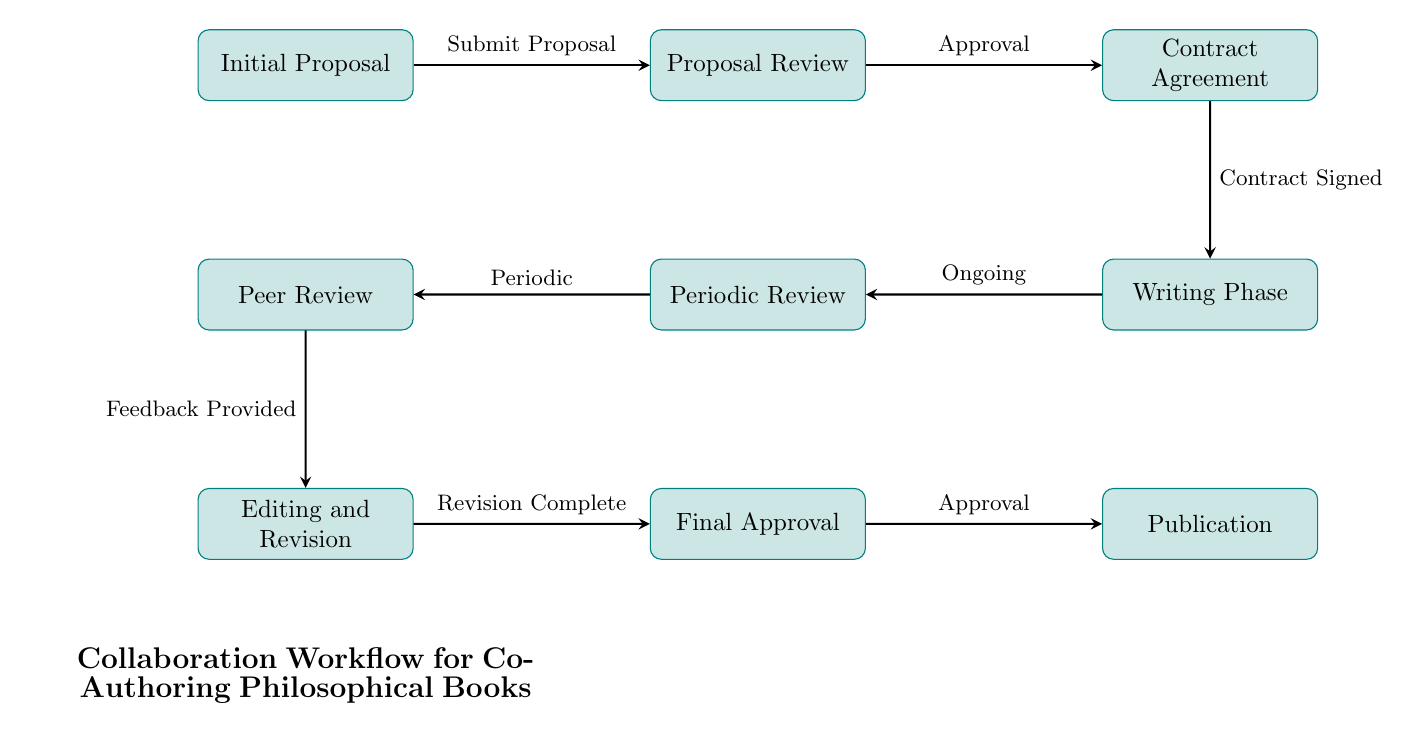What is the first step in the collaboration workflow? The first step in the workflow is "Initial Proposal," where authors submit their initial book proposals to the publisher.
Answer: Initial Proposal How many nodes are there in the diagram? The diagram contains a total of 9 nodes, each representing a different step in the collaboration workflow.
Answer: 9 What is the label of the node that follows the "Proposal Review" node? Following the "Proposal Review" node, the next node is labeled "Contract Agreement."
Answer: Contract Agreement What action triggers the "Periodic Review" node? The "Periodic Review" node is triggered by the "Writing Phase" node, which involves ongoing collaboration.
Answer: Ongoing Which node precedes the "Final Approval"? The node that precedes "Final Approval" is "Editing and Revision," where authors revise the manuscript based on feedback.
Answer: Editing and Revision What is the relationship between "Peer Review" and "Editing and Revision"? "Peer Review" provides feedback to "Editing and Revision," which means the manuscript is reviewed before it's revised.
Answer: Feedback Provided What is the last node in the workflow? The last node in the workflow is "Publication," signifying the release of the manuscript to the market.
Answer: Publication How many edges are connected to the "Writing Phase"? The "Writing Phase" node has 2 edges connected: one to "Periodic Review" and one to "Contract Agreement."
Answer: 2 What is the significance of the “Feedback Provided” action? The "Feedback Provided" action from "Peer Review" indicates that external philosophers review the manuscript to ensure academic quality before revisions.
Answer: Ensures academic quality 